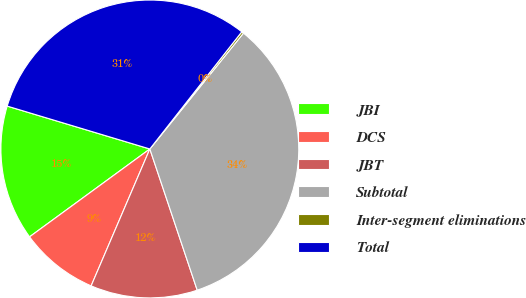Convert chart. <chart><loc_0><loc_0><loc_500><loc_500><pie_chart><fcel>JBI<fcel>DCS<fcel>JBT<fcel>Subtotal<fcel>Inter-segment eliminations<fcel>Total<nl><fcel>14.69%<fcel>8.51%<fcel>11.6%<fcel>34.03%<fcel>0.23%<fcel>30.94%<nl></chart> 